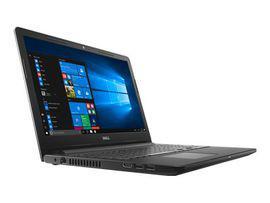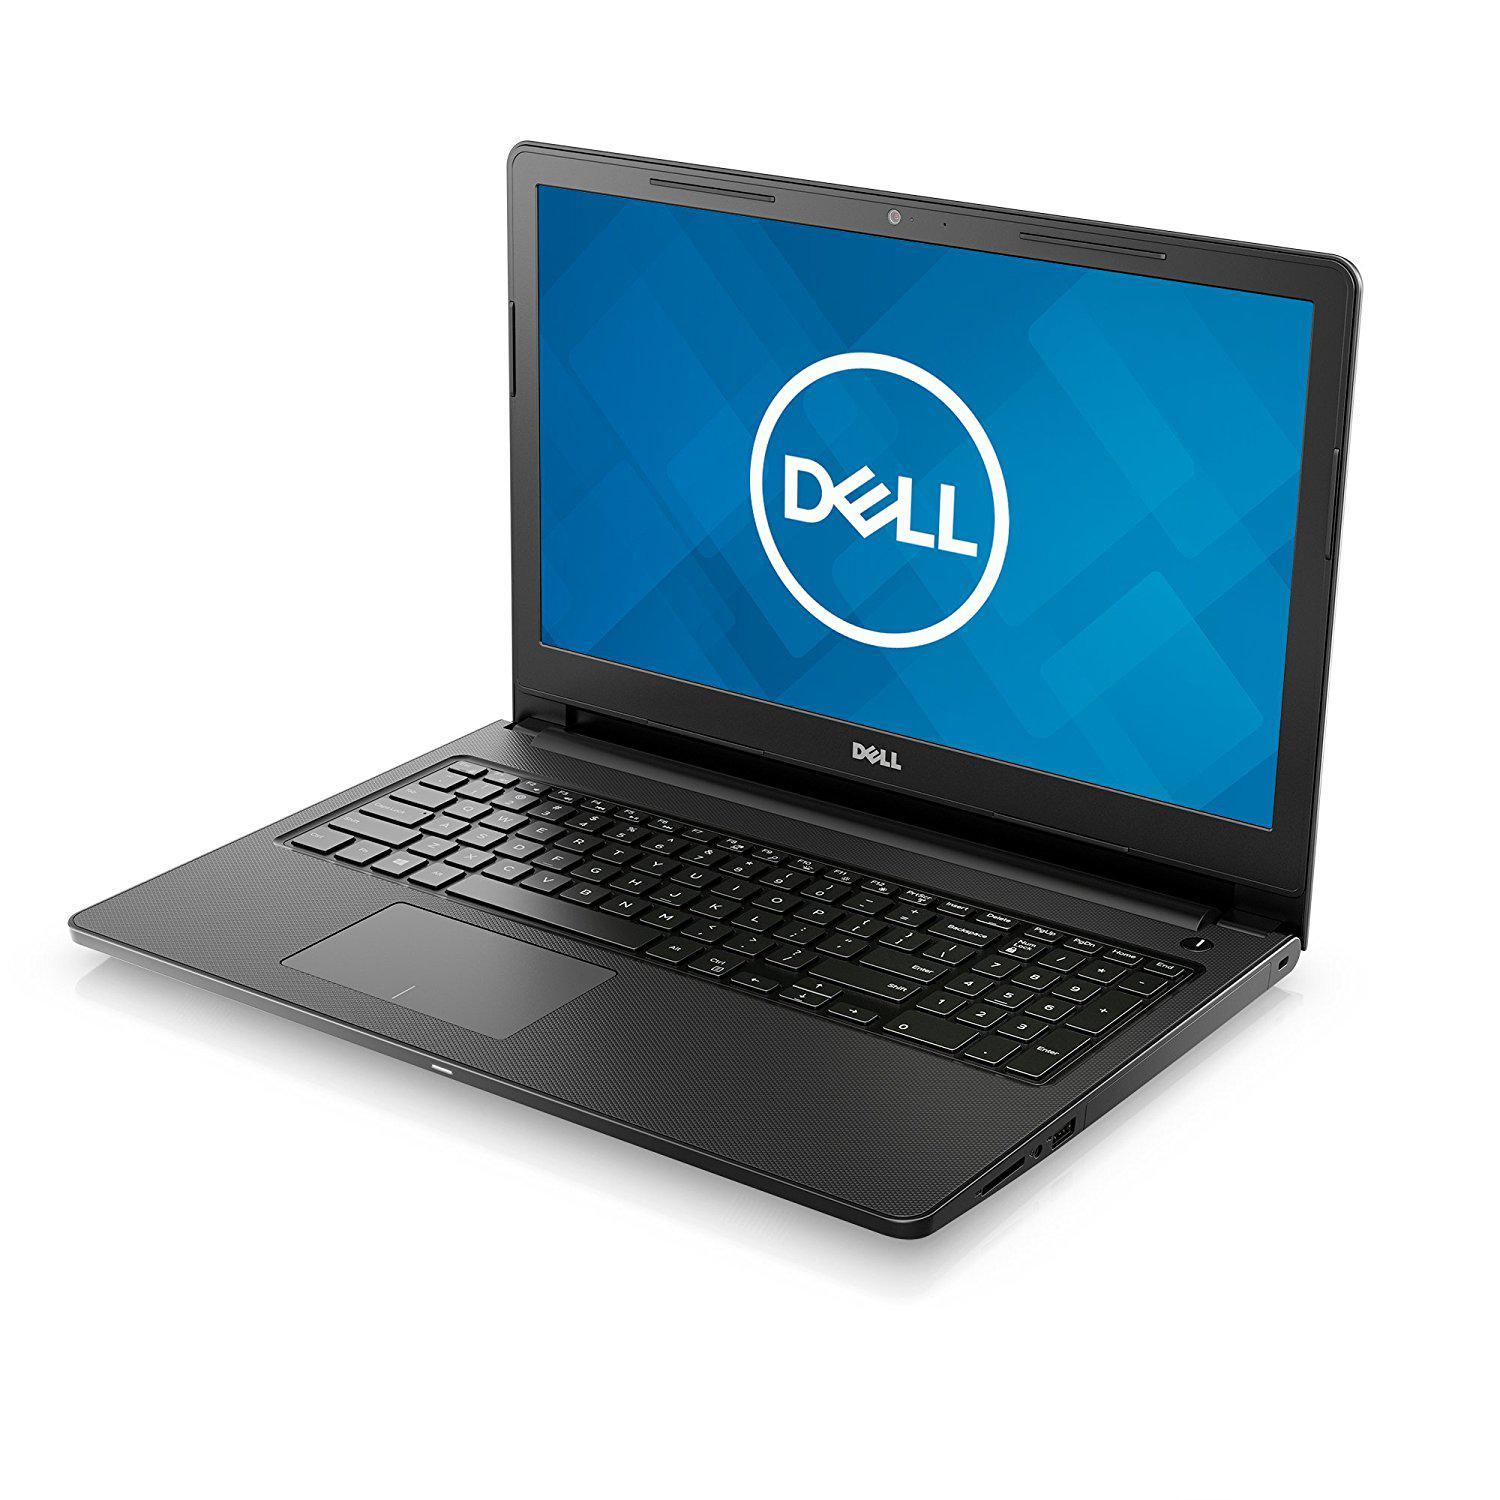The first image is the image on the left, the second image is the image on the right. Assess this claim about the two images: "The back side of a laptop is visible in one of the images.". Correct or not? Answer yes or no. No. The first image is the image on the left, the second image is the image on the right. Examine the images to the left and right. Is the description "All the laptops are fully open with visible screens." accurate? Answer yes or no. Yes. 